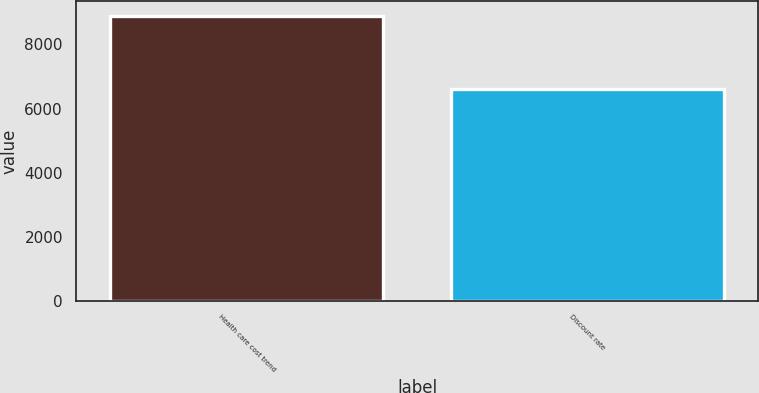<chart> <loc_0><loc_0><loc_500><loc_500><bar_chart><fcel>Health care cost trend<fcel>Discount rate<nl><fcel>8900<fcel>6622<nl></chart> 